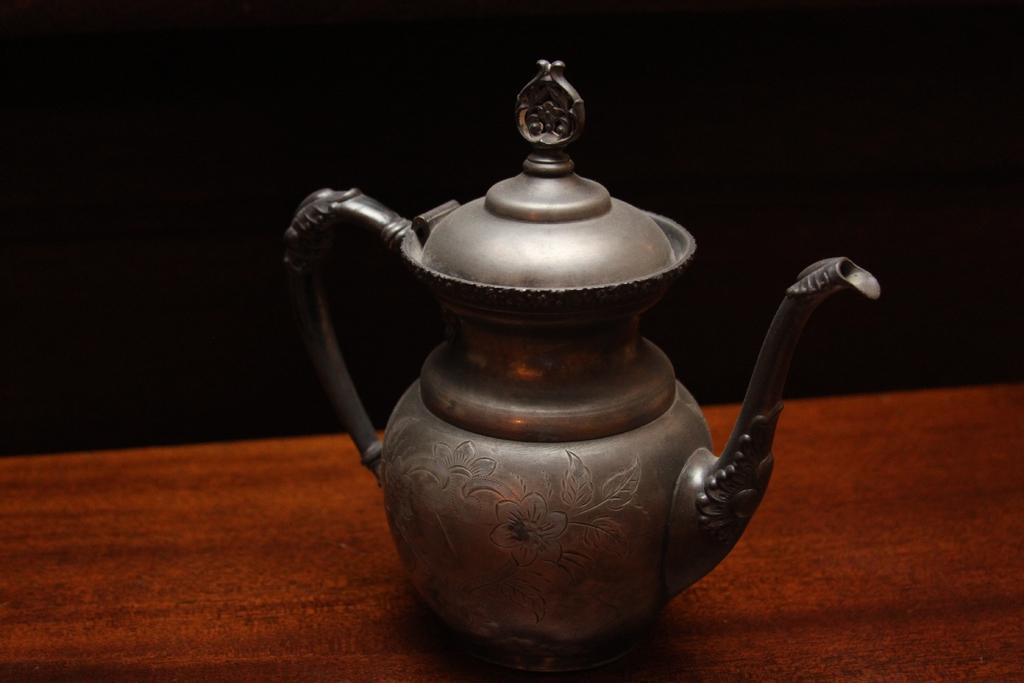What object is the main subject of the image? There is a teapot in the image. Where is the teapot located? The teapot is on a table. What design can be seen on the teapot? The teapot has a floral design. What color is the background of the image? The background of the image is black. What type of business is being conducted in the image? There is no indication of any business being conducted in the image; it primarily features a teapot on a table. Is there any blood visible in the image? No, there is no blood visible in the image. 